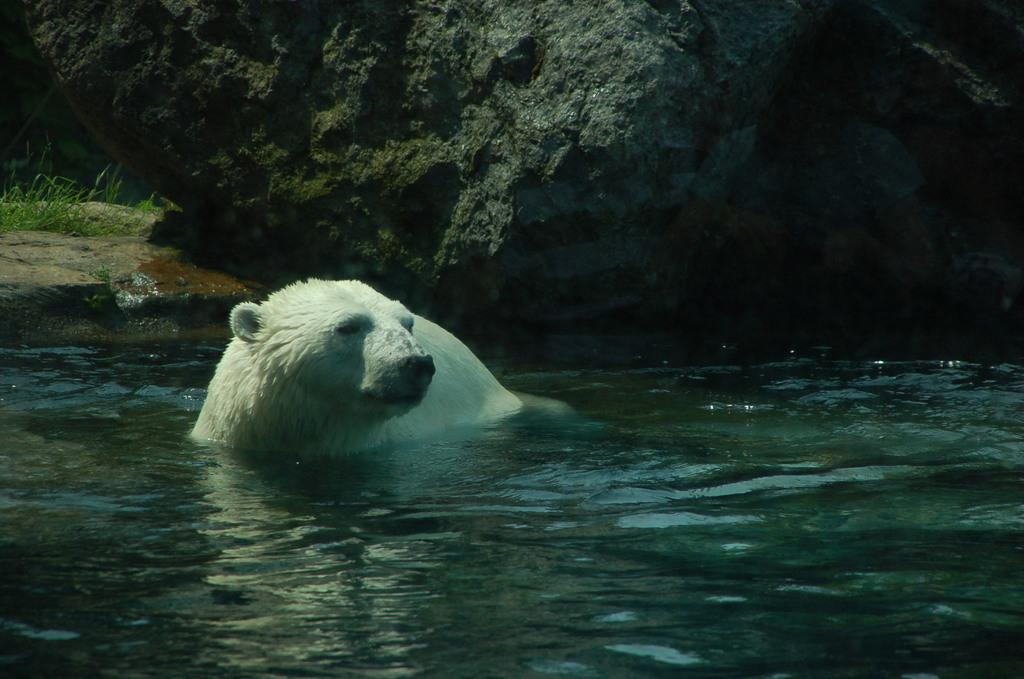What animal is in the image? There is a white polar bear in the image. Where is the polar bear located? The polar bear is in the water. What can be seen at the bottom of the image? There is water visible at the bottom of the image. What is present in the background of the image? There is a rock in the background of the image. What type of vegetation is on the left side of the image? There is green grass to the left of the image. Can you describe the stranger walking through the grass in the image? There is no stranger present in the image; it features a white polar bear in the water. What type of scarecrow is standing on the rock in the image? There is no scarecrow present in the image; it features a rock in the background. 